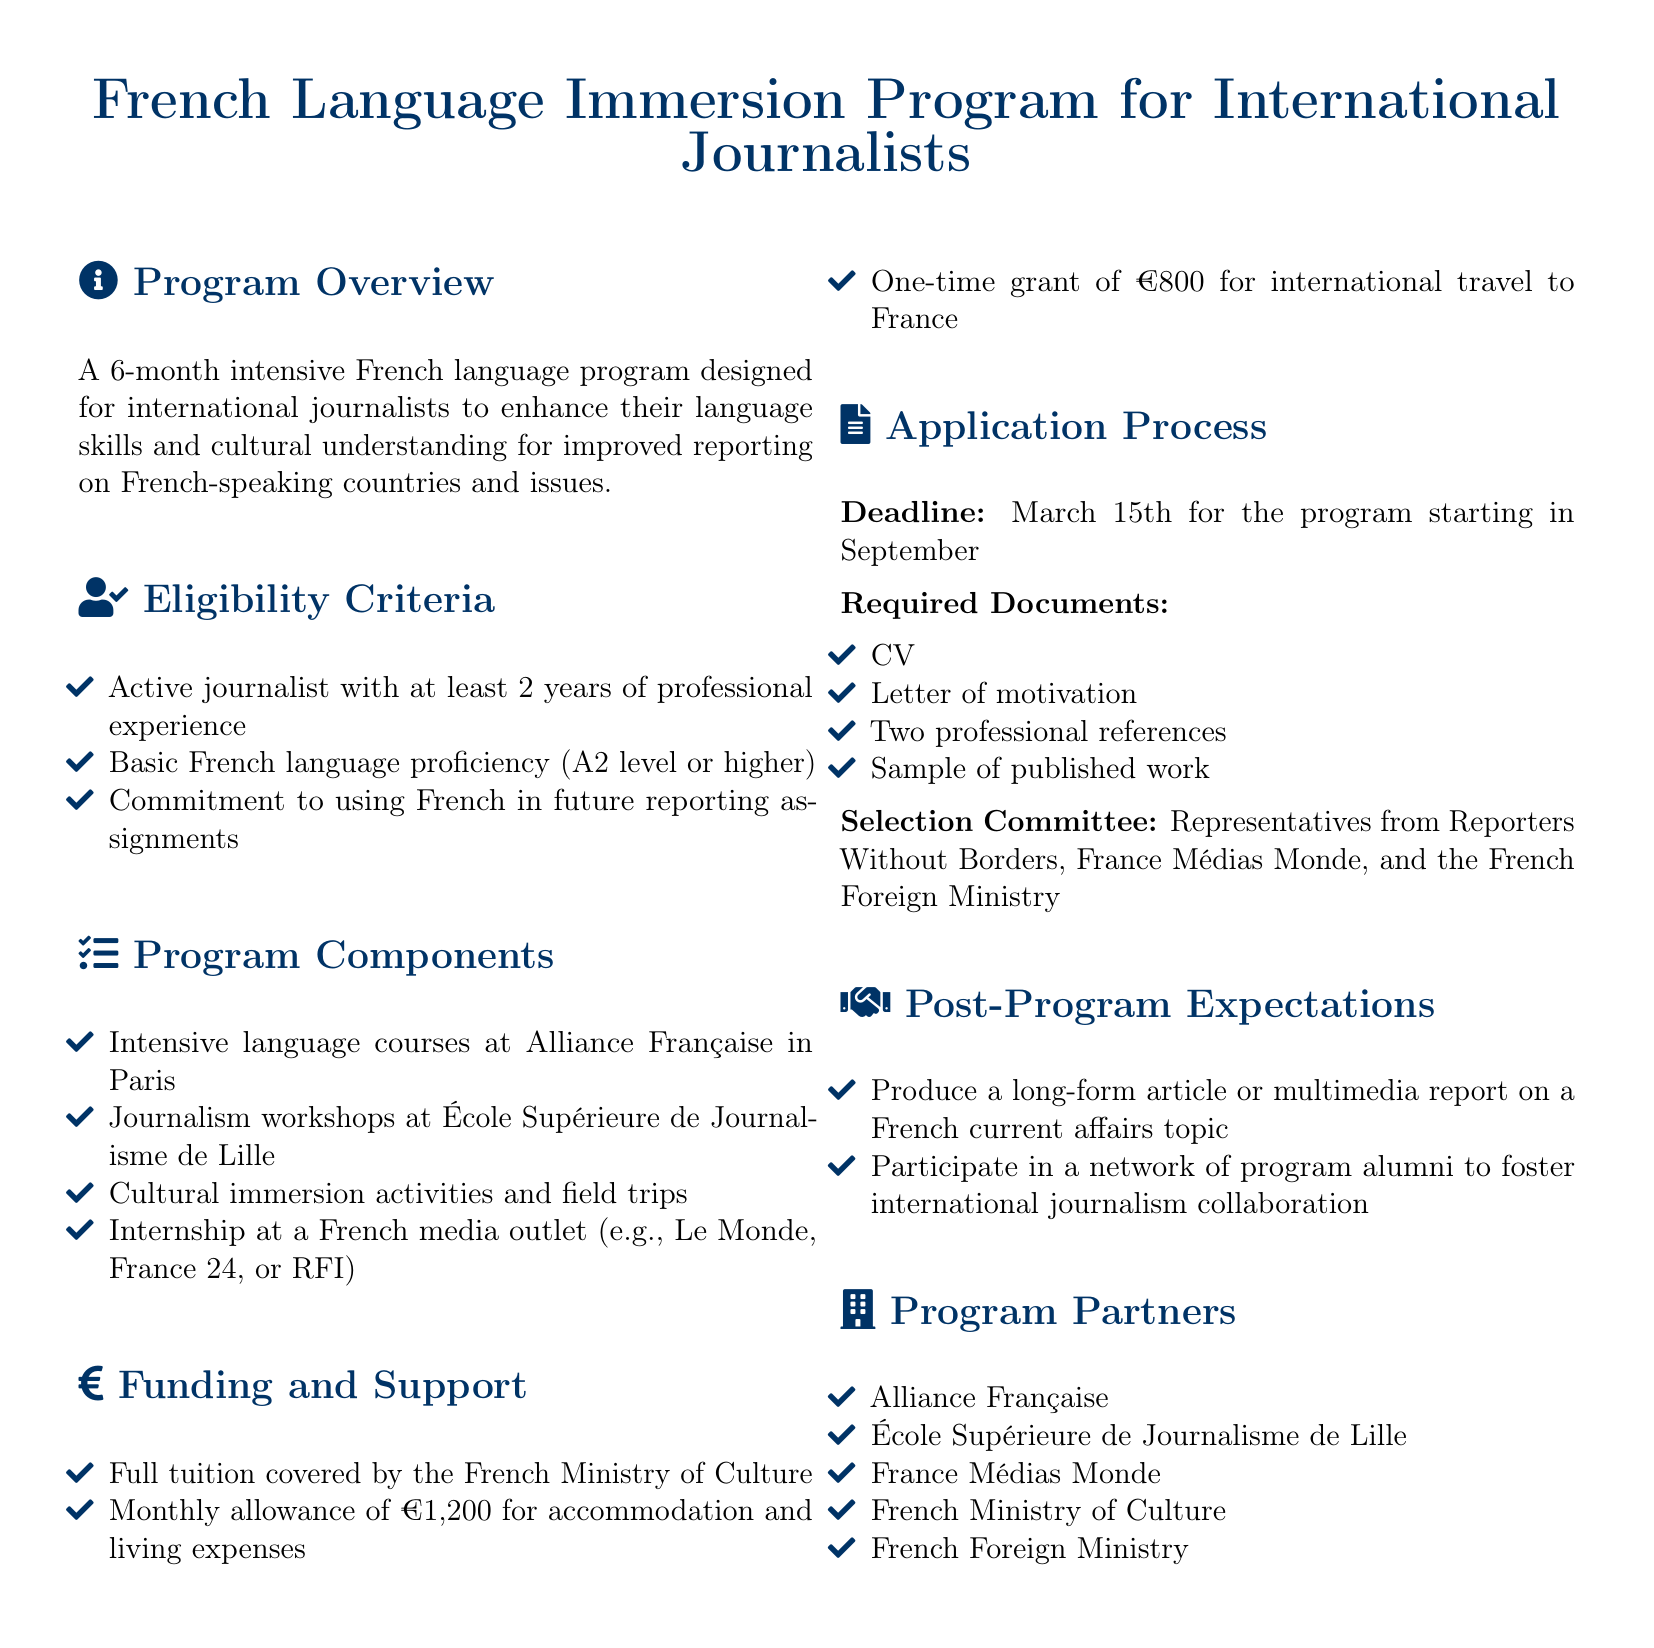What is the duration of the program? The duration of the program is specified in the overview section as being 6 months.
Answer: 6 months What financial support is offered for international travel? The document states that there is a one-time grant for international travel to France of €800.
Answer: €800 What is the eligibility requirement for French language proficiency? The eligibility criteria state that applicants must have basic French language proficiency of A2 level or higher.
Answer: A2 level or higher What institution provides the intensive language courses? The document specifies that intensive language courses are provided at Alliance Française in Paris.
Answer: Alliance Française When is the application deadline? The application process section mentions that the deadline is March 15th for the program starting in September.
Answer: March 15th What is the purpose of the post-program expectations? The expectations require producing a long-form article or multimedia report and participating in a network to foster collaboration.
Answer: Produce a long-form article or multimedia report How many professional references are required for the application? The application process section indicates that two professional references are needed.
Answer: Two professional references Who makes up the selection committee? The document lists that the selection committee includes representatives from Reporters Without Borders, France Médias Monde, and the French Foreign Ministry.
Answer: Reporters Without Borders, France Médias Monde, and the French Foreign Ministry What type of cultural activities are included in the program? The program components section mentions cultural immersion activities and field trips as part of the program.
Answer: Cultural immersion activities and field trips 